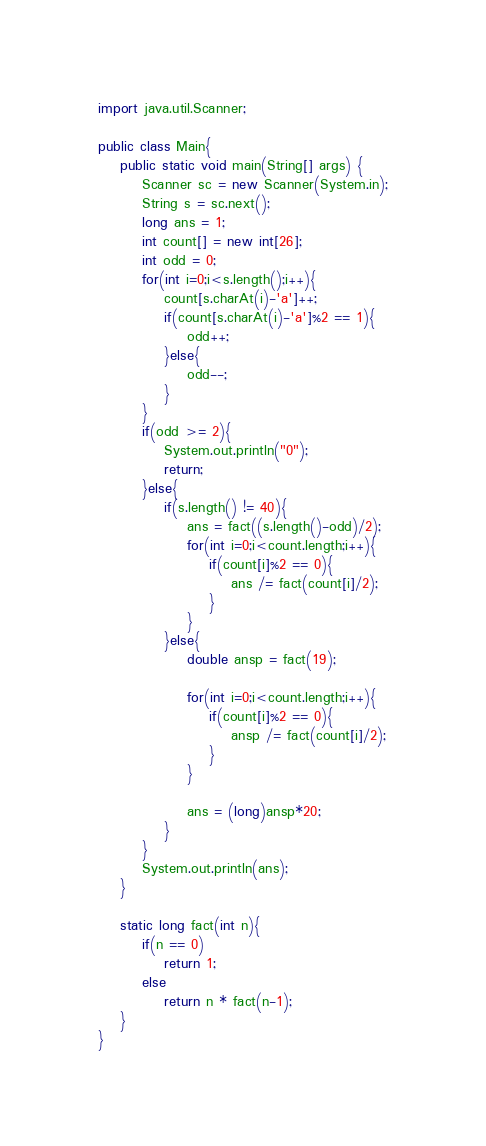Convert code to text. <code><loc_0><loc_0><loc_500><loc_500><_Java_>
import java.util.Scanner;

public class Main{
	public static void main(String[] args) {
		Scanner sc = new Scanner(System.in);
		String s = sc.next();
		long ans = 1;
		int count[] = new int[26];
		int odd = 0;
		for(int i=0;i<s.length();i++){
			count[s.charAt(i)-'a']++;
			if(count[s.charAt(i)-'a']%2 == 1){
				odd++;
			}else{
				odd--;
			}
		}
		if(odd >= 2){
			System.out.println("0");
			return;
		}else{
			if(s.length() != 40){
				ans = fact((s.length()-odd)/2);
				for(int i=0;i<count.length;i++){
					if(count[i]%2 == 0){
						ans /= fact(count[i]/2);
					}
				}
			}else{
				double ansp = fact(19);

				for(int i=0;i<count.length;i++){
					if(count[i]%2 == 0){
						ansp /= fact(count[i]/2);
					}
				}
				
				ans = (long)ansp*20;
			}
		}
		System.out.println(ans);
	}
	
	static long fact(int n){
		if(n == 0)
			return 1;
		else
			return n * fact(n-1);
	}
}</code> 